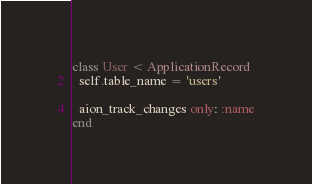<code> <loc_0><loc_0><loc_500><loc_500><_Ruby_>class User < ApplicationRecord
  self.table_name = 'users'

  aion_track_changes only: :name
end
</code> 